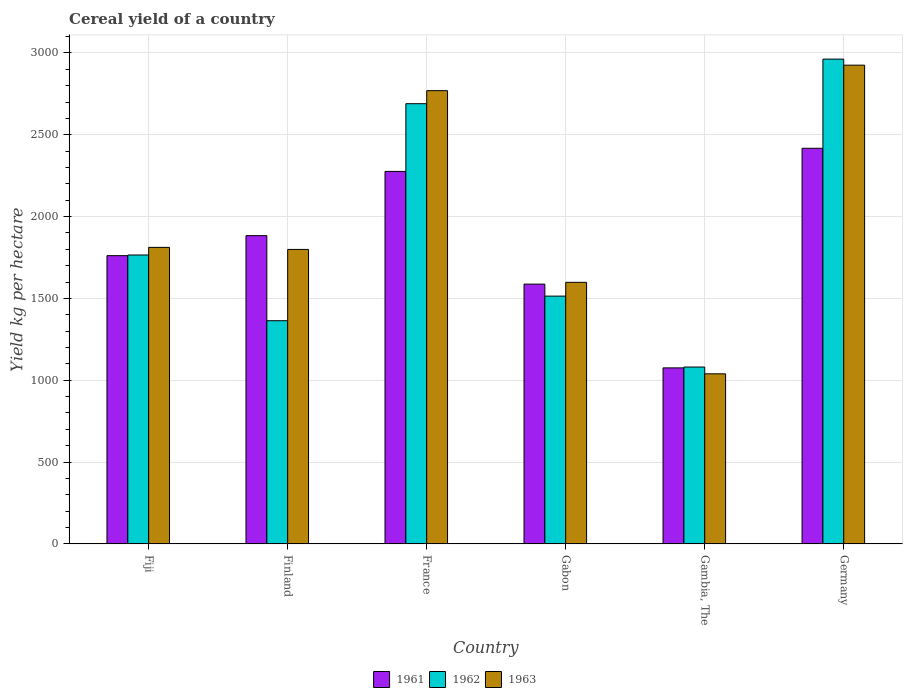How many different coloured bars are there?
Provide a short and direct response. 3. What is the label of the 3rd group of bars from the left?
Keep it short and to the point. France. What is the total cereal yield in 1963 in Fiji?
Your answer should be very brief. 1811.71. Across all countries, what is the maximum total cereal yield in 1963?
Ensure brevity in your answer.  2925.19. Across all countries, what is the minimum total cereal yield in 1963?
Offer a very short reply. 1039.04. In which country was the total cereal yield in 1961 maximum?
Make the answer very short. Germany. In which country was the total cereal yield in 1963 minimum?
Provide a succinct answer. Gambia, The. What is the total total cereal yield in 1962 in the graph?
Keep it short and to the point. 1.14e+04. What is the difference between the total cereal yield in 1961 in France and that in Gabon?
Offer a terse response. 688.73. What is the difference between the total cereal yield in 1963 in Gabon and the total cereal yield in 1962 in France?
Keep it short and to the point. -1091.63. What is the average total cereal yield in 1962 per country?
Provide a succinct answer. 1895.84. What is the difference between the total cereal yield of/in 1961 and total cereal yield of/in 1962 in Gabon?
Offer a terse response. 73.3. In how many countries, is the total cereal yield in 1963 greater than 2500 kg per hectare?
Make the answer very short. 2. What is the ratio of the total cereal yield in 1962 in Finland to that in Gabon?
Offer a terse response. 0.9. Is the difference between the total cereal yield in 1961 in Fiji and Gabon greater than the difference between the total cereal yield in 1962 in Fiji and Gabon?
Offer a terse response. No. What is the difference between the highest and the second highest total cereal yield in 1961?
Offer a terse response. 533.95. What is the difference between the highest and the lowest total cereal yield in 1962?
Offer a very short reply. 1881.68. In how many countries, is the total cereal yield in 1961 greater than the average total cereal yield in 1961 taken over all countries?
Your answer should be compact. 3. Is the sum of the total cereal yield in 1962 in Finland and Gambia, The greater than the maximum total cereal yield in 1961 across all countries?
Your response must be concise. Yes. Are all the bars in the graph horizontal?
Offer a very short reply. No. How many countries are there in the graph?
Offer a terse response. 6. What is the difference between two consecutive major ticks on the Y-axis?
Keep it short and to the point. 500. Are the values on the major ticks of Y-axis written in scientific E-notation?
Your response must be concise. No. Does the graph contain grids?
Keep it short and to the point. Yes. How are the legend labels stacked?
Keep it short and to the point. Horizontal. What is the title of the graph?
Ensure brevity in your answer.  Cereal yield of a country. Does "1964" appear as one of the legend labels in the graph?
Offer a terse response. No. What is the label or title of the Y-axis?
Offer a terse response. Yield kg per hectare. What is the Yield kg per hectare of 1961 in Fiji?
Offer a terse response. 1761.1. What is the Yield kg per hectare in 1962 in Fiji?
Offer a very short reply. 1765.19. What is the Yield kg per hectare in 1963 in Fiji?
Your response must be concise. 1811.71. What is the Yield kg per hectare of 1961 in Finland?
Provide a short and direct response. 1883.41. What is the Yield kg per hectare in 1962 in Finland?
Offer a very short reply. 1363.64. What is the Yield kg per hectare of 1963 in Finland?
Offer a terse response. 1799.22. What is the Yield kg per hectare of 1961 in France?
Offer a very short reply. 2275.91. What is the Yield kg per hectare in 1962 in France?
Offer a terse response. 2689.71. What is the Yield kg per hectare in 1963 in France?
Give a very brief answer. 2769.43. What is the Yield kg per hectare in 1961 in Gabon?
Keep it short and to the point. 1587.18. What is the Yield kg per hectare in 1962 in Gabon?
Provide a succinct answer. 1513.88. What is the Yield kg per hectare of 1963 in Gabon?
Provide a succinct answer. 1598.08. What is the Yield kg per hectare of 1961 in Gambia, The?
Your answer should be very brief. 1075.34. What is the Yield kg per hectare in 1962 in Gambia, The?
Keep it short and to the point. 1080.48. What is the Yield kg per hectare of 1963 in Gambia, The?
Offer a terse response. 1039.04. What is the Yield kg per hectare of 1961 in Germany?
Offer a very short reply. 2417.36. What is the Yield kg per hectare in 1962 in Germany?
Ensure brevity in your answer.  2962.16. What is the Yield kg per hectare in 1963 in Germany?
Provide a succinct answer. 2925.19. Across all countries, what is the maximum Yield kg per hectare of 1961?
Provide a short and direct response. 2417.36. Across all countries, what is the maximum Yield kg per hectare in 1962?
Give a very brief answer. 2962.16. Across all countries, what is the maximum Yield kg per hectare in 1963?
Ensure brevity in your answer.  2925.19. Across all countries, what is the minimum Yield kg per hectare in 1961?
Your answer should be very brief. 1075.34. Across all countries, what is the minimum Yield kg per hectare in 1962?
Provide a short and direct response. 1080.48. Across all countries, what is the minimum Yield kg per hectare of 1963?
Make the answer very short. 1039.04. What is the total Yield kg per hectare in 1961 in the graph?
Keep it short and to the point. 1.10e+04. What is the total Yield kg per hectare of 1962 in the graph?
Your response must be concise. 1.14e+04. What is the total Yield kg per hectare in 1963 in the graph?
Your response must be concise. 1.19e+04. What is the difference between the Yield kg per hectare in 1961 in Fiji and that in Finland?
Your answer should be compact. -122.3. What is the difference between the Yield kg per hectare in 1962 in Fiji and that in Finland?
Keep it short and to the point. 401.54. What is the difference between the Yield kg per hectare of 1963 in Fiji and that in Finland?
Offer a terse response. 12.49. What is the difference between the Yield kg per hectare in 1961 in Fiji and that in France?
Provide a succinct answer. -514.8. What is the difference between the Yield kg per hectare of 1962 in Fiji and that in France?
Your response must be concise. -924.52. What is the difference between the Yield kg per hectare in 1963 in Fiji and that in France?
Give a very brief answer. -957.72. What is the difference between the Yield kg per hectare in 1961 in Fiji and that in Gabon?
Keep it short and to the point. 173.92. What is the difference between the Yield kg per hectare of 1962 in Fiji and that in Gabon?
Ensure brevity in your answer.  251.31. What is the difference between the Yield kg per hectare in 1963 in Fiji and that in Gabon?
Make the answer very short. 213.63. What is the difference between the Yield kg per hectare of 1961 in Fiji and that in Gambia, The?
Offer a very short reply. 685.76. What is the difference between the Yield kg per hectare of 1962 in Fiji and that in Gambia, The?
Offer a very short reply. 684.7. What is the difference between the Yield kg per hectare in 1963 in Fiji and that in Gambia, The?
Your answer should be very brief. 772.67. What is the difference between the Yield kg per hectare of 1961 in Fiji and that in Germany?
Offer a terse response. -656.26. What is the difference between the Yield kg per hectare of 1962 in Fiji and that in Germany?
Your answer should be compact. -1196.97. What is the difference between the Yield kg per hectare of 1963 in Fiji and that in Germany?
Make the answer very short. -1113.48. What is the difference between the Yield kg per hectare of 1961 in Finland and that in France?
Your response must be concise. -392.5. What is the difference between the Yield kg per hectare of 1962 in Finland and that in France?
Your answer should be compact. -1326.06. What is the difference between the Yield kg per hectare in 1963 in Finland and that in France?
Provide a short and direct response. -970.21. What is the difference between the Yield kg per hectare of 1961 in Finland and that in Gabon?
Make the answer very short. 296.23. What is the difference between the Yield kg per hectare of 1962 in Finland and that in Gabon?
Make the answer very short. -150.24. What is the difference between the Yield kg per hectare in 1963 in Finland and that in Gabon?
Provide a succinct answer. 201.14. What is the difference between the Yield kg per hectare of 1961 in Finland and that in Gambia, The?
Give a very brief answer. 808.07. What is the difference between the Yield kg per hectare in 1962 in Finland and that in Gambia, The?
Make the answer very short. 283.16. What is the difference between the Yield kg per hectare in 1963 in Finland and that in Gambia, The?
Offer a very short reply. 760.18. What is the difference between the Yield kg per hectare of 1961 in Finland and that in Germany?
Make the answer very short. -533.95. What is the difference between the Yield kg per hectare of 1962 in Finland and that in Germany?
Provide a short and direct response. -1598.52. What is the difference between the Yield kg per hectare in 1963 in Finland and that in Germany?
Provide a short and direct response. -1125.96. What is the difference between the Yield kg per hectare in 1961 in France and that in Gabon?
Keep it short and to the point. 688.73. What is the difference between the Yield kg per hectare of 1962 in France and that in Gabon?
Offer a very short reply. 1175.83. What is the difference between the Yield kg per hectare in 1963 in France and that in Gabon?
Make the answer very short. 1171.35. What is the difference between the Yield kg per hectare of 1961 in France and that in Gambia, The?
Provide a short and direct response. 1200.57. What is the difference between the Yield kg per hectare of 1962 in France and that in Gambia, The?
Your answer should be compact. 1609.23. What is the difference between the Yield kg per hectare in 1963 in France and that in Gambia, The?
Your answer should be very brief. 1730.39. What is the difference between the Yield kg per hectare of 1961 in France and that in Germany?
Give a very brief answer. -141.45. What is the difference between the Yield kg per hectare in 1962 in France and that in Germany?
Your answer should be very brief. -272.45. What is the difference between the Yield kg per hectare in 1963 in France and that in Germany?
Offer a very short reply. -155.75. What is the difference between the Yield kg per hectare of 1961 in Gabon and that in Gambia, The?
Give a very brief answer. 511.84. What is the difference between the Yield kg per hectare of 1962 in Gabon and that in Gambia, The?
Provide a succinct answer. 433.4. What is the difference between the Yield kg per hectare in 1963 in Gabon and that in Gambia, The?
Provide a succinct answer. 559.04. What is the difference between the Yield kg per hectare of 1961 in Gabon and that in Germany?
Provide a succinct answer. -830.18. What is the difference between the Yield kg per hectare in 1962 in Gabon and that in Germany?
Offer a terse response. -1448.28. What is the difference between the Yield kg per hectare in 1963 in Gabon and that in Germany?
Provide a short and direct response. -1327.1. What is the difference between the Yield kg per hectare in 1961 in Gambia, The and that in Germany?
Offer a very short reply. -1342.02. What is the difference between the Yield kg per hectare of 1962 in Gambia, The and that in Germany?
Provide a succinct answer. -1881.68. What is the difference between the Yield kg per hectare of 1963 in Gambia, The and that in Germany?
Your answer should be very brief. -1886.14. What is the difference between the Yield kg per hectare of 1961 in Fiji and the Yield kg per hectare of 1962 in Finland?
Your answer should be compact. 397.46. What is the difference between the Yield kg per hectare in 1961 in Fiji and the Yield kg per hectare in 1963 in Finland?
Provide a short and direct response. -38.12. What is the difference between the Yield kg per hectare of 1962 in Fiji and the Yield kg per hectare of 1963 in Finland?
Ensure brevity in your answer.  -34.04. What is the difference between the Yield kg per hectare in 1961 in Fiji and the Yield kg per hectare in 1962 in France?
Provide a succinct answer. -928.61. What is the difference between the Yield kg per hectare in 1961 in Fiji and the Yield kg per hectare in 1963 in France?
Make the answer very short. -1008.33. What is the difference between the Yield kg per hectare in 1962 in Fiji and the Yield kg per hectare in 1963 in France?
Your answer should be very brief. -1004.25. What is the difference between the Yield kg per hectare of 1961 in Fiji and the Yield kg per hectare of 1962 in Gabon?
Your answer should be compact. 247.22. What is the difference between the Yield kg per hectare in 1961 in Fiji and the Yield kg per hectare in 1963 in Gabon?
Provide a succinct answer. 163.02. What is the difference between the Yield kg per hectare in 1962 in Fiji and the Yield kg per hectare in 1963 in Gabon?
Provide a short and direct response. 167.1. What is the difference between the Yield kg per hectare in 1961 in Fiji and the Yield kg per hectare in 1962 in Gambia, The?
Keep it short and to the point. 680.62. What is the difference between the Yield kg per hectare in 1961 in Fiji and the Yield kg per hectare in 1963 in Gambia, The?
Provide a succinct answer. 722.06. What is the difference between the Yield kg per hectare in 1962 in Fiji and the Yield kg per hectare in 1963 in Gambia, The?
Your answer should be very brief. 726.14. What is the difference between the Yield kg per hectare of 1961 in Fiji and the Yield kg per hectare of 1962 in Germany?
Offer a very short reply. -1201.06. What is the difference between the Yield kg per hectare in 1961 in Fiji and the Yield kg per hectare in 1963 in Germany?
Ensure brevity in your answer.  -1164.08. What is the difference between the Yield kg per hectare of 1962 in Fiji and the Yield kg per hectare of 1963 in Germany?
Offer a very short reply. -1160. What is the difference between the Yield kg per hectare of 1961 in Finland and the Yield kg per hectare of 1962 in France?
Ensure brevity in your answer.  -806.3. What is the difference between the Yield kg per hectare in 1961 in Finland and the Yield kg per hectare in 1963 in France?
Offer a very short reply. -886.03. What is the difference between the Yield kg per hectare of 1962 in Finland and the Yield kg per hectare of 1963 in France?
Offer a very short reply. -1405.79. What is the difference between the Yield kg per hectare in 1961 in Finland and the Yield kg per hectare in 1962 in Gabon?
Provide a short and direct response. 369.53. What is the difference between the Yield kg per hectare of 1961 in Finland and the Yield kg per hectare of 1963 in Gabon?
Your answer should be compact. 285.32. What is the difference between the Yield kg per hectare of 1962 in Finland and the Yield kg per hectare of 1963 in Gabon?
Give a very brief answer. -234.44. What is the difference between the Yield kg per hectare in 1961 in Finland and the Yield kg per hectare in 1962 in Gambia, The?
Your answer should be compact. 802.92. What is the difference between the Yield kg per hectare in 1961 in Finland and the Yield kg per hectare in 1963 in Gambia, The?
Offer a terse response. 844.37. What is the difference between the Yield kg per hectare of 1962 in Finland and the Yield kg per hectare of 1963 in Gambia, The?
Ensure brevity in your answer.  324.6. What is the difference between the Yield kg per hectare of 1961 in Finland and the Yield kg per hectare of 1962 in Germany?
Provide a succinct answer. -1078.75. What is the difference between the Yield kg per hectare of 1961 in Finland and the Yield kg per hectare of 1963 in Germany?
Give a very brief answer. -1041.78. What is the difference between the Yield kg per hectare of 1962 in Finland and the Yield kg per hectare of 1963 in Germany?
Your response must be concise. -1561.54. What is the difference between the Yield kg per hectare of 1961 in France and the Yield kg per hectare of 1962 in Gabon?
Your answer should be very brief. 762.03. What is the difference between the Yield kg per hectare in 1961 in France and the Yield kg per hectare in 1963 in Gabon?
Make the answer very short. 677.82. What is the difference between the Yield kg per hectare of 1962 in France and the Yield kg per hectare of 1963 in Gabon?
Offer a very short reply. 1091.62. What is the difference between the Yield kg per hectare in 1961 in France and the Yield kg per hectare in 1962 in Gambia, The?
Ensure brevity in your answer.  1195.42. What is the difference between the Yield kg per hectare in 1961 in France and the Yield kg per hectare in 1963 in Gambia, The?
Give a very brief answer. 1236.87. What is the difference between the Yield kg per hectare in 1962 in France and the Yield kg per hectare in 1963 in Gambia, The?
Provide a succinct answer. 1650.67. What is the difference between the Yield kg per hectare of 1961 in France and the Yield kg per hectare of 1962 in Germany?
Provide a succinct answer. -686.25. What is the difference between the Yield kg per hectare in 1961 in France and the Yield kg per hectare in 1963 in Germany?
Give a very brief answer. -649.28. What is the difference between the Yield kg per hectare in 1962 in France and the Yield kg per hectare in 1963 in Germany?
Offer a very short reply. -235.48. What is the difference between the Yield kg per hectare in 1961 in Gabon and the Yield kg per hectare in 1962 in Gambia, The?
Offer a very short reply. 506.7. What is the difference between the Yield kg per hectare in 1961 in Gabon and the Yield kg per hectare in 1963 in Gambia, The?
Your answer should be compact. 548.14. What is the difference between the Yield kg per hectare in 1962 in Gabon and the Yield kg per hectare in 1963 in Gambia, The?
Your response must be concise. 474.84. What is the difference between the Yield kg per hectare of 1961 in Gabon and the Yield kg per hectare of 1962 in Germany?
Keep it short and to the point. -1374.98. What is the difference between the Yield kg per hectare in 1961 in Gabon and the Yield kg per hectare in 1963 in Germany?
Offer a very short reply. -1338.01. What is the difference between the Yield kg per hectare of 1962 in Gabon and the Yield kg per hectare of 1963 in Germany?
Ensure brevity in your answer.  -1411.31. What is the difference between the Yield kg per hectare of 1961 in Gambia, The and the Yield kg per hectare of 1962 in Germany?
Make the answer very short. -1886.82. What is the difference between the Yield kg per hectare in 1961 in Gambia, The and the Yield kg per hectare in 1963 in Germany?
Make the answer very short. -1849.85. What is the difference between the Yield kg per hectare of 1962 in Gambia, The and the Yield kg per hectare of 1963 in Germany?
Offer a very short reply. -1844.7. What is the average Yield kg per hectare in 1961 per country?
Keep it short and to the point. 1833.38. What is the average Yield kg per hectare of 1962 per country?
Provide a short and direct response. 1895.84. What is the average Yield kg per hectare in 1963 per country?
Provide a short and direct response. 1990.45. What is the difference between the Yield kg per hectare in 1961 and Yield kg per hectare in 1962 in Fiji?
Keep it short and to the point. -4.08. What is the difference between the Yield kg per hectare of 1961 and Yield kg per hectare of 1963 in Fiji?
Provide a short and direct response. -50.61. What is the difference between the Yield kg per hectare in 1962 and Yield kg per hectare in 1963 in Fiji?
Offer a very short reply. -46.52. What is the difference between the Yield kg per hectare in 1961 and Yield kg per hectare in 1962 in Finland?
Ensure brevity in your answer.  519.76. What is the difference between the Yield kg per hectare of 1961 and Yield kg per hectare of 1963 in Finland?
Offer a terse response. 84.18. What is the difference between the Yield kg per hectare of 1962 and Yield kg per hectare of 1963 in Finland?
Your answer should be compact. -435.58. What is the difference between the Yield kg per hectare of 1961 and Yield kg per hectare of 1962 in France?
Your answer should be compact. -413.8. What is the difference between the Yield kg per hectare of 1961 and Yield kg per hectare of 1963 in France?
Your answer should be compact. -493.53. What is the difference between the Yield kg per hectare of 1962 and Yield kg per hectare of 1963 in France?
Your answer should be compact. -79.72. What is the difference between the Yield kg per hectare of 1961 and Yield kg per hectare of 1962 in Gabon?
Provide a succinct answer. 73.3. What is the difference between the Yield kg per hectare of 1961 and Yield kg per hectare of 1963 in Gabon?
Provide a succinct answer. -10.9. What is the difference between the Yield kg per hectare of 1962 and Yield kg per hectare of 1963 in Gabon?
Ensure brevity in your answer.  -84.2. What is the difference between the Yield kg per hectare in 1961 and Yield kg per hectare in 1962 in Gambia, The?
Provide a short and direct response. -5.14. What is the difference between the Yield kg per hectare in 1961 and Yield kg per hectare in 1963 in Gambia, The?
Provide a short and direct response. 36.3. What is the difference between the Yield kg per hectare of 1962 and Yield kg per hectare of 1963 in Gambia, The?
Provide a succinct answer. 41.44. What is the difference between the Yield kg per hectare in 1961 and Yield kg per hectare in 1962 in Germany?
Your answer should be compact. -544.8. What is the difference between the Yield kg per hectare in 1961 and Yield kg per hectare in 1963 in Germany?
Offer a terse response. -507.83. What is the difference between the Yield kg per hectare of 1962 and Yield kg per hectare of 1963 in Germany?
Your response must be concise. 36.97. What is the ratio of the Yield kg per hectare in 1961 in Fiji to that in Finland?
Provide a succinct answer. 0.94. What is the ratio of the Yield kg per hectare in 1962 in Fiji to that in Finland?
Your answer should be very brief. 1.29. What is the ratio of the Yield kg per hectare in 1961 in Fiji to that in France?
Ensure brevity in your answer.  0.77. What is the ratio of the Yield kg per hectare in 1962 in Fiji to that in France?
Offer a terse response. 0.66. What is the ratio of the Yield kg per hectare in 1963 in Fiji to that in France?
Give a very brief answer. 0.65. What is the ratio of the Yield kg per hectare of 1961 in Fiji to that in Gabon?
Keep it short and to the point. 1.11. What is the ratio of the Yield kg per hectare in 1962 in Fiji to that in Gabon?
Make the answer very short. 1.17. What is the ratio of the Yield kg per hectare of 1963 in Fiji to that in Gabon?
Offer a very short reply. 1.13. What is the ratio of the Yield kg per hectare of 1961 in Fiji to that in Gambia, The?
Offer a terse response. 1.64. What is the ratio of the Yield kg per hectare of 1962 in Fiji to that in Gambia, The?
Your answer should be very brief. 1.63. What is the ratio of the Yield kg per hectare of 1963 in Fiji to that in Gambia, The?
Give a very brief answer. 1.74. What is the ratio of the Yield kg per hectare in 1961 in Fiji to that in Germany?
Your answer should be compact. 0.73. What is the ratio of the Yield kg per hectare in 1962 in Fiji to that in Germany?
Offer a very short reply. 0.6. What is the ratio of the Yield kg per hectare of 1963 in Fiji to that in Germany?
Give a very brief answer. 0.62. What is the ratio of the Yield kg per hectare in 1961 in Finland to that in France?
Give a very brief answer. 0.83. What is the ratio of the Yield kg per hectare in 1962 in Finland to that in France?
Your answer should be very brief. 0.51. What is the ratio of the Yield kg per hectare of 1963 in Finland to that in France?
Offer a very short reply. 0.65. What is the ratio of the Yield kg per hectare in 1961 in Finland to that in Gabon?
Keep it short and to the point. 1.19. What is the ratio of the Yield kg per hectare of 1962 in Finland to that in Gabon?
Keep it short and to the point. 0.9. What is the ratio of the Yield kg per hectare in 1963 in Finland to that in Gabon?
Ensure brevity in your answer.  1.13. What is the ratio of the Yield kg per hectare in 1961 in Finland to that in Gambia, The?
Your answer should be compact. 1.75. What is the ratio of the Yield kg per hectare of 1962 in Finland to that in Gambia, The?
Ensure brevity in your answer.  1.26. What is the ratio of the Yield kg per hectare in 1963 in Finland to that in Gambia, The?
Give a very brief answer. 1.73. What is the ratio of the Yield kg per hectare in 1961 in Finland to that in Germany?
Keep it short and to the point. 0.78. What is the ratio of the Yield kg per hectare of 1962 in Finland to that in Germany?
Ensure brevity in your answer.  0.46. What is the ratio of the Yield kg per hectare in 1963 in Finland to that in Germany?
Your answer should be compact. 0.62. What is the ratio of the Yield kg per hectare of 1961 in France to that in Gabon?
Provide a short and direct response. 1.43. What is the ratio of the Yield kg per hectare in 1962 in France to that in Gabon?
Offer a very short reply. 1.78. What is the ratio of the Yield kg per hectare of 1963 in France to that in Gabon?
Your answer should be compact. 1.73. What is the ratio of the Yield kg per hectare in 1961 in France to that in Gambia, The?
Offer a very short reply. 2.12. What is the ratio of the Yield kg per hectare of 1962 in France to that in Gambia, The?
Offer a very short reply. 2.49. What is the ratio of the Yield kg per hectare of 1963 in France to that in Gambia, The?
Your answer should be very brief. 2.67. What is the ratio of the Yield kg per hectare in 1961 in France to that in Germany?
Ensure brevity in your answer.  0.94. What is the ratio of the Yield kg per hectare in 1962 in France to that in Germany?
Give a very brief answer. 0.91. What is the ratio of the Yield kg per hectare in 1963 in France to that in Germany?
Offer a very short reply. 0.95. What is the ratio of the Yield kg per hectare of 1961 in Gabon to that in Gambia, The?
Offer a very short reply. 1.48. What is the ratio of the Yield kg per hectare in 1962 in Gabon to that in Gambia, The?
Offer a very short reply. 1.4. What is the ratio of the Yield kg per hectare of 1963 in Gabon to that in Gambia, The?
Provide a succinct answer. 1.54. What is the ratio of the Yield kg per hectare of 1961 in Gabon to that in Germany?
Provide a succinct answer. 0.66. What is the ratio of the Yield kg per hectare of 1962 in Gabon to that in Germany?
Make the answer very short. 0.51. What is the ratio of the Yield kg per hectare of 1963 in Gabon to that in Germany?
Keep it short and to the point. 0.55. What is the ratio of the Yield kg per hectare of 1961 in Gambia, The to that in Germany?
Your response must be concise. 0.44. What is the ratio of the Yield kg per hectare of 1962 in Gambia, The to that in Germany?
Your response must be concise. 0.36. What is the ratio of the Yield kg per hectare in 1963 in Gambia, The to that in Germany?
Provide a succinct answer. 0.36. What is the difference between the highest and the second highest Yield kg per hectare of 1961?
Provide a short and direct response. 141.45. What is the difference between the highest and the second highest Yield kg per hectare of 1962?
Ensure brevity in your answer.  272.45. What is the difference between the highest and the second highest Yield kg per hectare in 1963?
Your answer should be very brief. 155.75. What is the difference between the highest and the lowest Yield kg per hectare of 1961?
Offer a terse response. 1342.02. What is the difference between the highest and the lowest Yield kg per hectare in 1962?
Your answer should be compact. 1881.68. What is the difference between the highest and the lowest Yield kg per hectare in 1963?
Provide a succinct answer. 1886.14. 